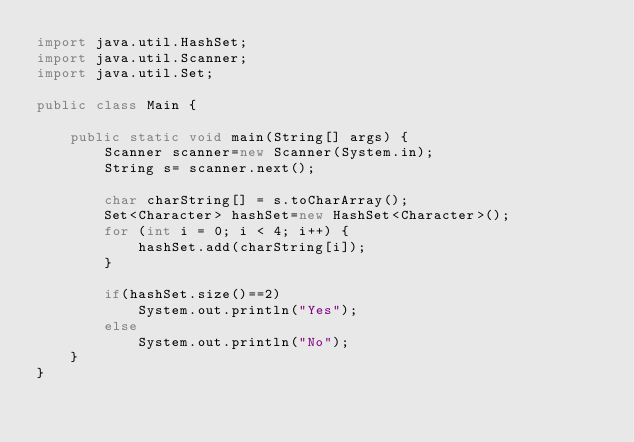Convert code to text. <code><loc_0><loc_0><loc_500><loc_500><_Java_>import java.util.HashSet;
import java.util.Scanner;
import java.util.Set;

public class Main {

    public static void main(String[] args) {
        Scanner scanner=new Scanner(System.in);
        String s= scanner.next();

        char charString[] = s.toCharArray();
        Set<Character> hashSet=new HashSet<Character>();
        for (int i = 0; i < 4; i++) {
            hashSet.add(charString[i]);
        }

        if(hashSet.size()==2)
            System.out.println("Yes");
        else
            System.out.println("No");
    }
}</code> 